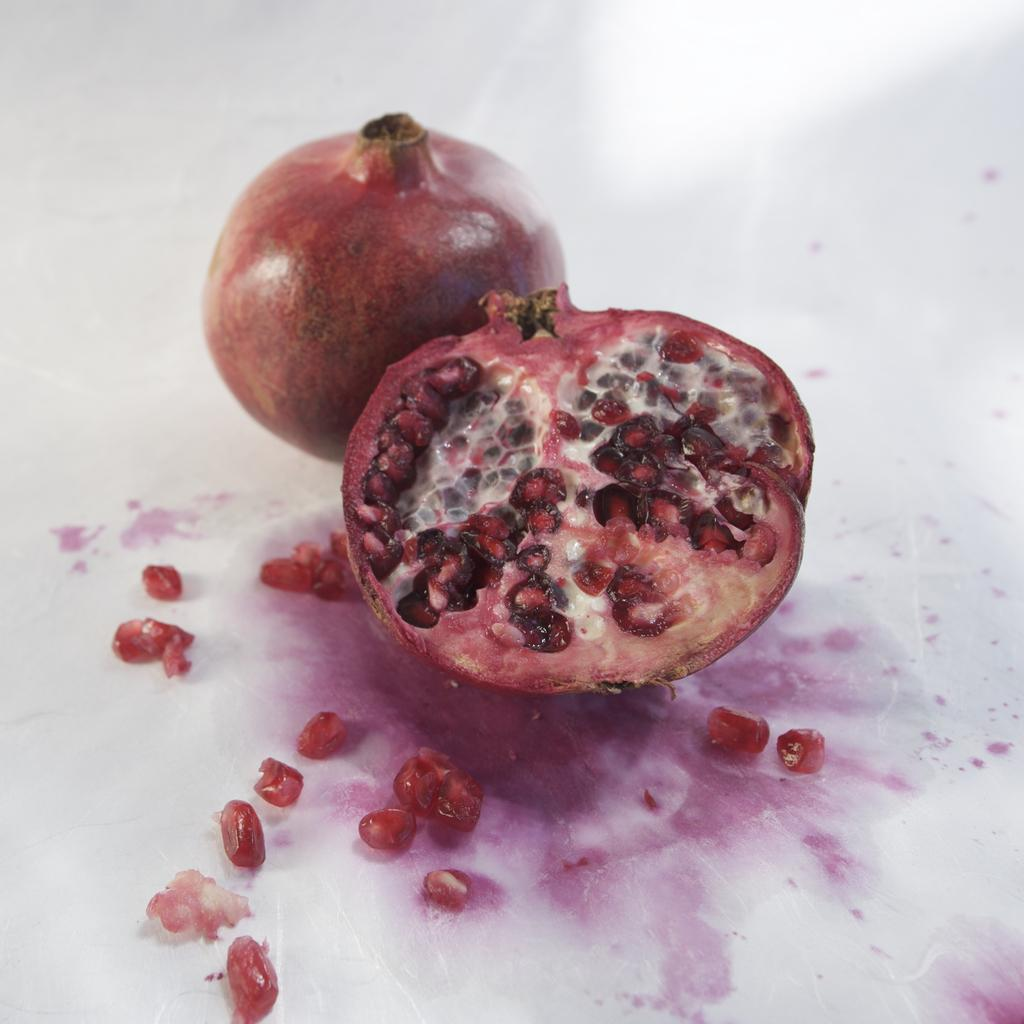What type of fruit is the main subject of the image? There is a pomegranate in the image. How is the pomegranate presented in the image? There is a sliced piece of a pomegranate in the image. What can be seen inside the pomegranate? Pomegranate seeds are visible in the image. What type of apparatus is being used to spy on the pomegranate in the image? There is no apparatus or spying activity present in the image; it simply shows a pomegranate and its sliced piece with visible seeds. 